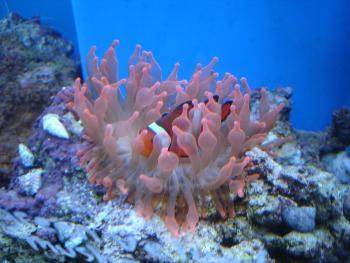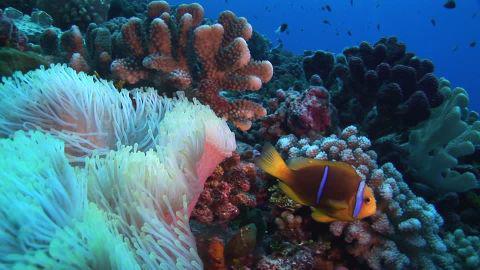The first image is the image on the left, the second image is the image on the right. For the images displayed, is the sentence "Each image shows multiple fish with white stripes swimming above anemone tendrils, and the left image features anemone tendrils with non-tapered yellow tips." factually correct? Answer yes or no. No. The first image is the image on the left, the second image is the image on the right. Considering the images on both sides, is "A single fish is swimming near the sea plant in the image on the left." valid? Answer yes or no. Yes. 